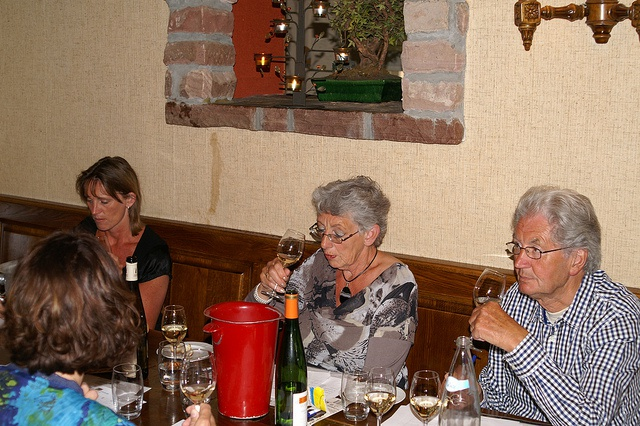Describe the objects in this image and their specific colors. I can see people in gray, darkgray, and lightgray tones, bench in gray, black, and maroon tones, people in gray, black, maroon, and lightblue tones, people in gray, darkgray, and black tones, and people in gray, black, maroon, and brown tones in this image. 